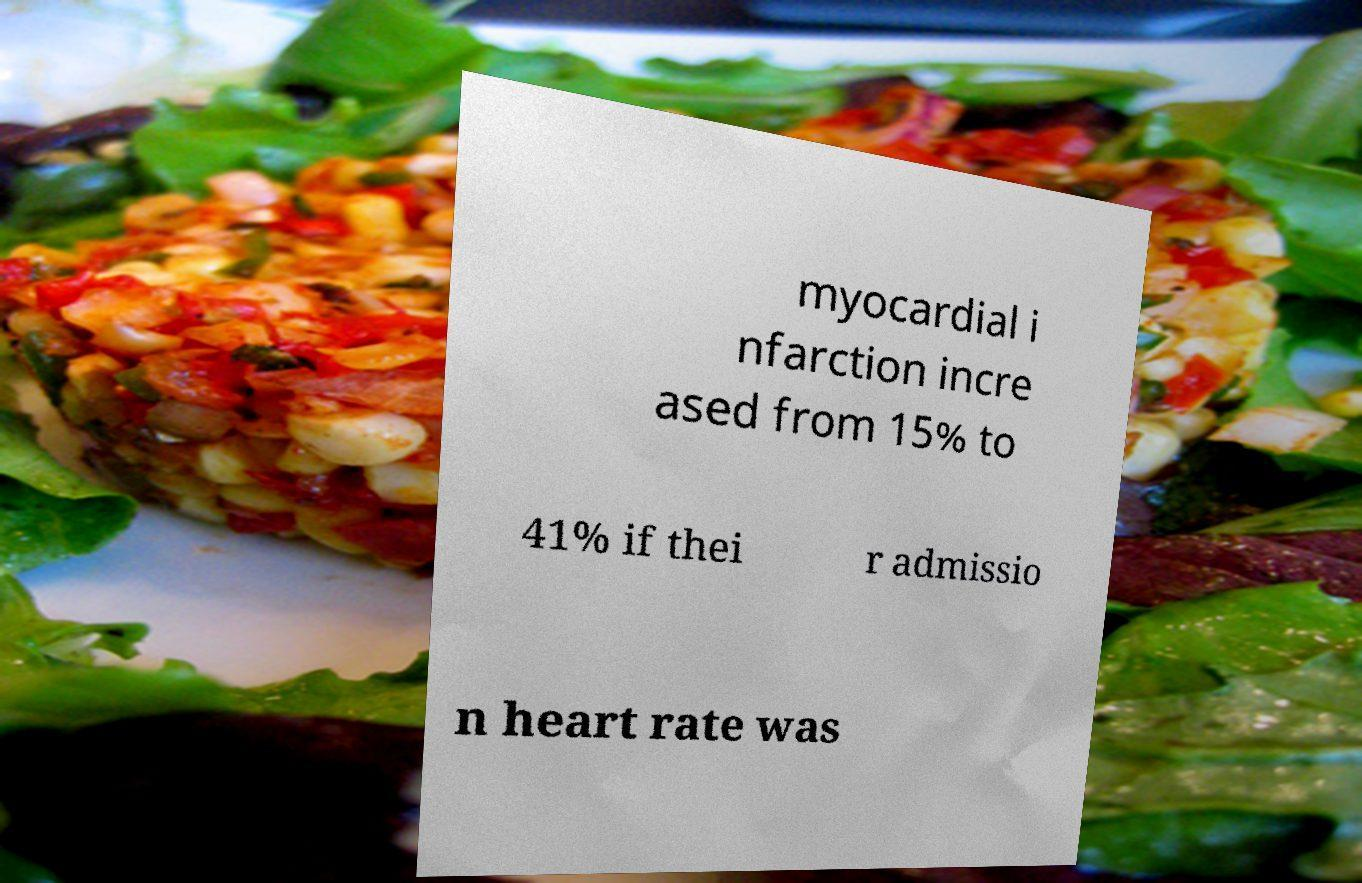Could you extract and type out the text from this image? myocardial i nfarction incre ased from 15% to 41% if thei r admissio n heart rate was 